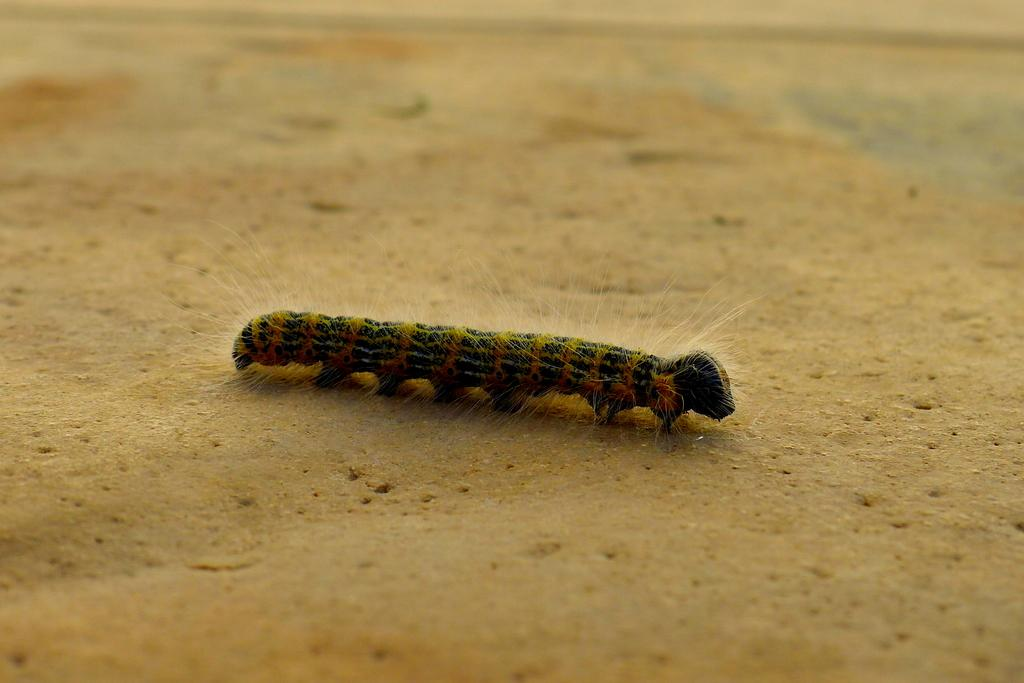What type of creature is in the image? There is an insect in the image, which appears to be a caterpillar. Where is the caterpillar located in the image? The caterpillar is in the center of the image. What is the surface on which the caterpillar is resting? The caterpillar is on the ground. What type of chair is visible in the image? There is no chair present in the image; it features a caterpillar on the ground. Can you tell me how many bats are flying in the image? There are no bats present in the image; it features a caterpillar on the ground. 